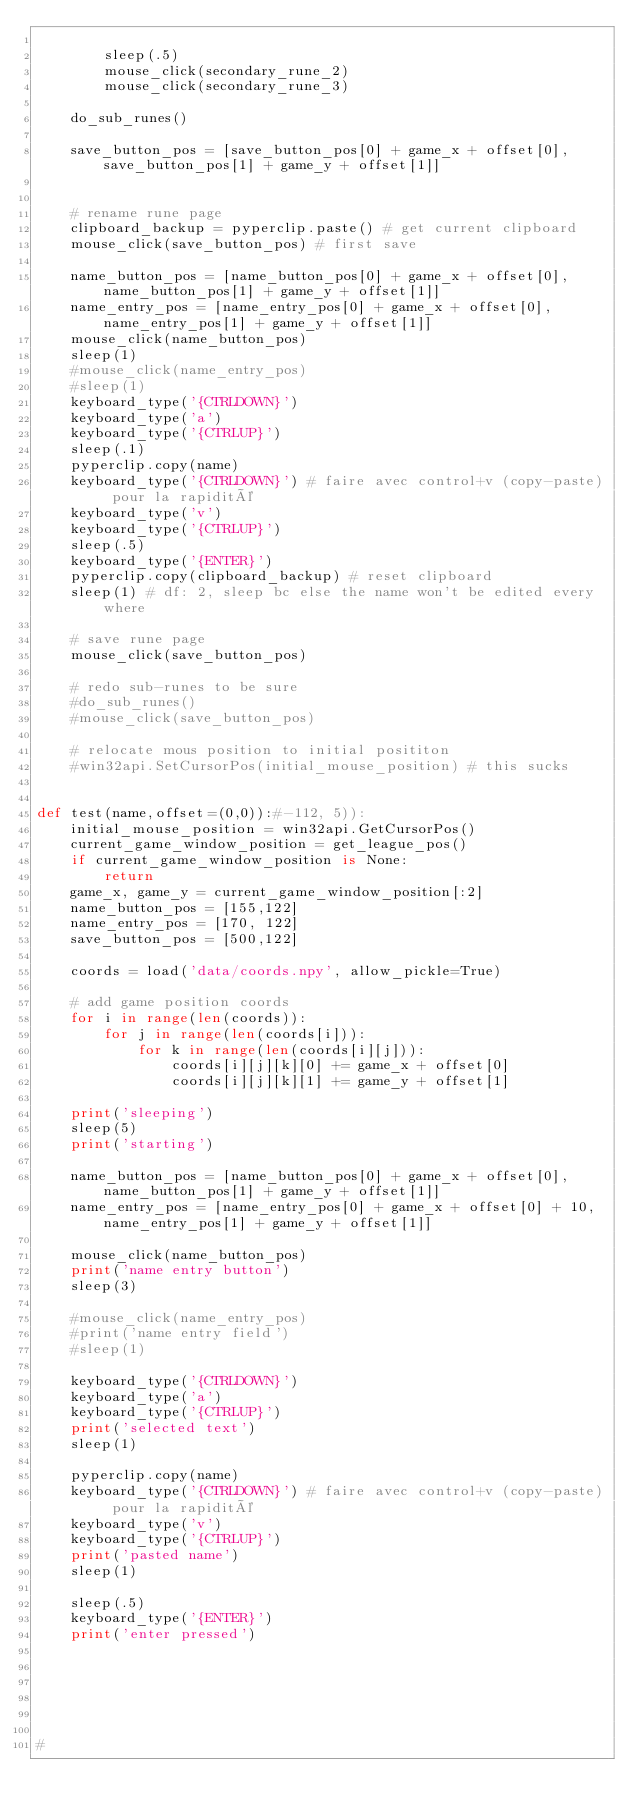Convert code to text. <code><loc_0><loc_0><loc_500><loc_500><_Python_>
        sleep(.5)
        mouse_click(secondary_rune_2)
        mouse_click(secondary_rune_3)

    do_sub_runes()

    save_button_pos = [save_button_pos[0] + game_x + offset[0], save_button_pos[1] + game_y + offset[1]]


    # rename rune page
    clipboard_backup = pyperclip.paste() # get current clipboard
    mouse_click(save_button_pos) # first save

    name_button_pos = [name_button_pos[0] + game_x + offset[0], name_button_pos[1] + game_y + offset[1]]
    name_entry_pos = [name_entry_pos[0] + game_x + offset[0], name_entry_pos[1] + game_y + offset[1]]
    mouse_click(name_button_pos)
    sleep(1)
    #mouse_click(name_entry_pos)
    #sleep(1)
    keyboard_type('{CTRLDOWN}')
    keyboard_type('a')
    keyboard_type('{CTRLUP}')
    sleep(.1)
    pyperclip.copy(name)
    keyboard_type('{CTRLDOWN}') # faire avec control+v (copy-paste) pour la rapidité
    keyboard_type('v')
    keyboard_type('{CTRLUP}')
    sleep(.5)
    keyboard_type('{ENTER}')
    pyperclip.copy(clipboard_backup) # reset clipboard
    sleep(1) # df: 2, sleep bc else the name won't be edited every where

    # save rune page
    mouse_click(save_button_pos)

    # redo sub-runes to be sure
    #do_sub_runes()
    #mouse_click(save_button_pos)

    # relocate mous position to initial posititon
    #win32api.SetCursorPos(initial_mouse_position) # this sucks


def test(name,offset=(0,0)):#-112, 5)):
    initial_mouse_position = win32api.GetCursorPos()
    current_game_window_position = get_league_pos()
    if current_game_window_position is None:
        return
    game_x, game_y = current_game_window_position[:2]
    name_button_pos = [155,122]
    name_entry_pos = [170, 122]
    save_button_pos = [500,122]

    coords = load('data/coords.npy', allow_pickle=True)

    # add game position coords
    for i in range(len(coords)):
        for j in range(len(coords[i])):
            for k in range(len(coords[i][j])):
                coords[i][j][k][0] += game_x + offset[0]
                coords[i][j][k][1] += game_y + offset[1]

    print('sleeping')
    sleep(5)
    print('starting')

    name_button_pos = [name_button_pos[0] + game_x + offset[0], name_button_pos[1] + game_y + offset[1]]
    name_entry_pos = [name_entry_pos[0] + game_x + offset[0] + 10, name_entry_pos[1] + game_y + offset[1]]

    mouse_click(name_button_pos)
    print('name entry button')
    sleep(3)

    #mouse_click(name_entry_pos)
    #print('name entry field')
    #sleep(1)

    keyboard_type('{CTRLDOWN}')
    keyboard_type('a')
    keyboard_type('{CTRLUP}')
    print('selected text')
    sleep(1)

    pyperclip.copy(name)
    keyboard_type('{CTRLDOWN}') # faire avec control+v (copy-paste) pour la rapidité
    keyboard_type('v')
    keyboard_type('{CTRLUP}')
    print('pasted name')
    sleep(1)

    sleep(.5)
    keyboard_type('{ENTER}')
    print('enter pressed')






#
</code> 